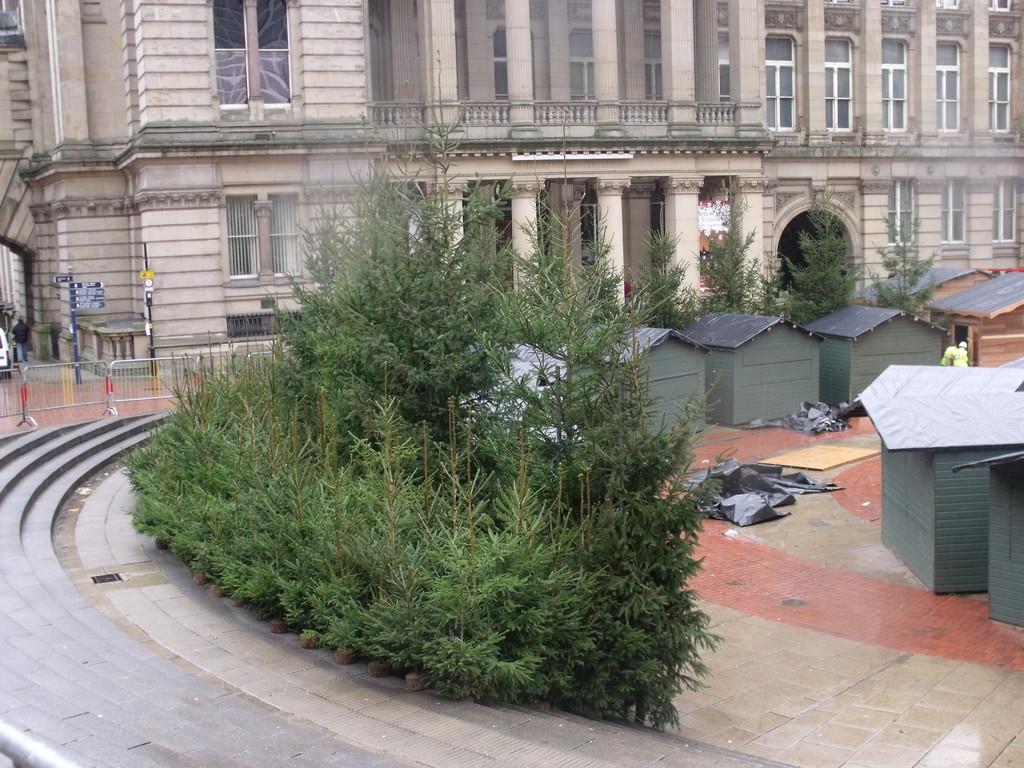Can you describe this image briefly? Here in this picture we can see a building with number of windows on it present over there and in the front of it we can see number of plants and trees present over there and we can also see small rooms with roofs on it present on the ground over there and on the left side we can see barricades present and we can also see sign boards present on poles over there and on the left side we can see steps present over there. 